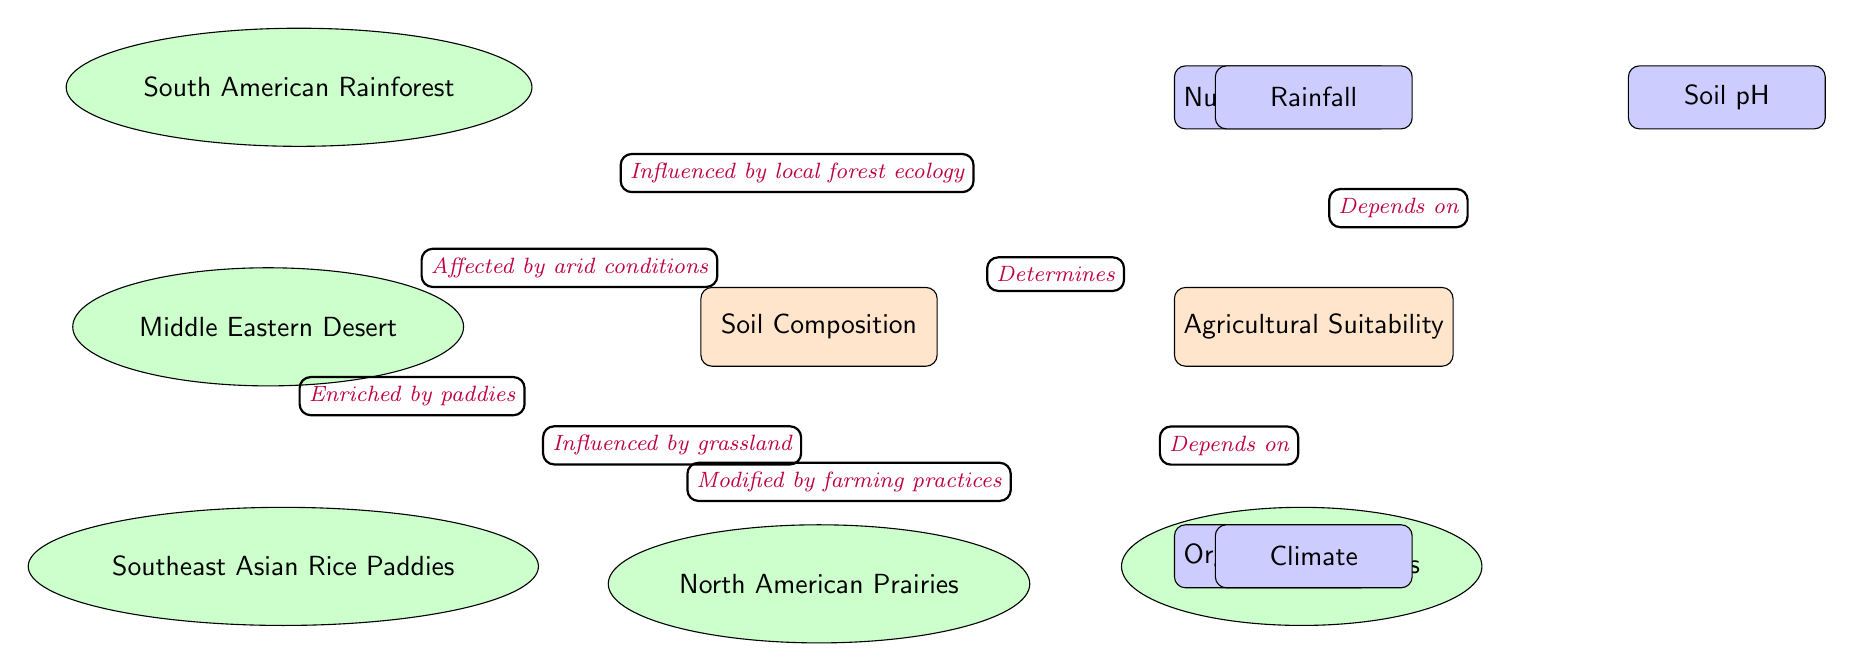What is the main focus of the diagram? The main focus of the diagram is identified in the central node labeled "Soil Composition." This node connects to various other nodes that represent factors and regions related to agricultural suitability.
Answer: Soil Composition Which region is influenced by local forest ecology? The diagram indicates that "South American Rainforest" influences the "Soil Composition" through a directed edge that describes the relationship as influenced by local forest ecology.
Answer: South American Rainforest How many factors are listed that affect agricultural suitability? The diagram shows a total of four factors connected to the node "Agricultural Suitability." These factors are "Nutrient Content," "Soil pH," "Organic Matter," and "Climate."
Answer: Four What does the "Middle Eastern Desert" affect in the diagram? According to the directed edge connecting "Middle Eastern Desert" to "Soil Composition," it is described as being affected by arid conditions, showing its influence on soil quality.
Answer: Soil Composition Which factor depends on rainfall according to the diagram? In the diagram, "Agricultural Suitability" receives an incoming edge labeled "Depends on" from the "Rainfall" factor, indicating that rainfall is essential for determining agricultural potential.
Answer: Agricultural Suitability What agricultural factor depends on climate? The diagram specifically shows that "Agricultural Suitability" is influenced by "Climate," as evidenced by the edge labeled "Depends on" connecting them.
Answer: Agricultural Suitability How is the soil in the "European Farmlands" modified? The diagram describes the modification of soil in "European Farmlands" as being influenced by farming practices, which is articulated through the directed edge pointing from that region to the "Soil Composition" node.
Answer: Farming practices What is the relationship between "Soil Composition" and "Agricultural Suitability"? The relationship is established by a directed edge labeled "Determines," indicating that the composition of soil plays a critical role in determining agricultural suitability in given regions.
Answer: Determines Which region's soil is enriched by paddies? The diagram specifies that "Southeast Asian Rice Paddies" are enriched by their unique farming system, and this is represented in the diagram with a designated edge pointing towards "Soil Composition."
Answer: Southeast Asian Rice Paddies 